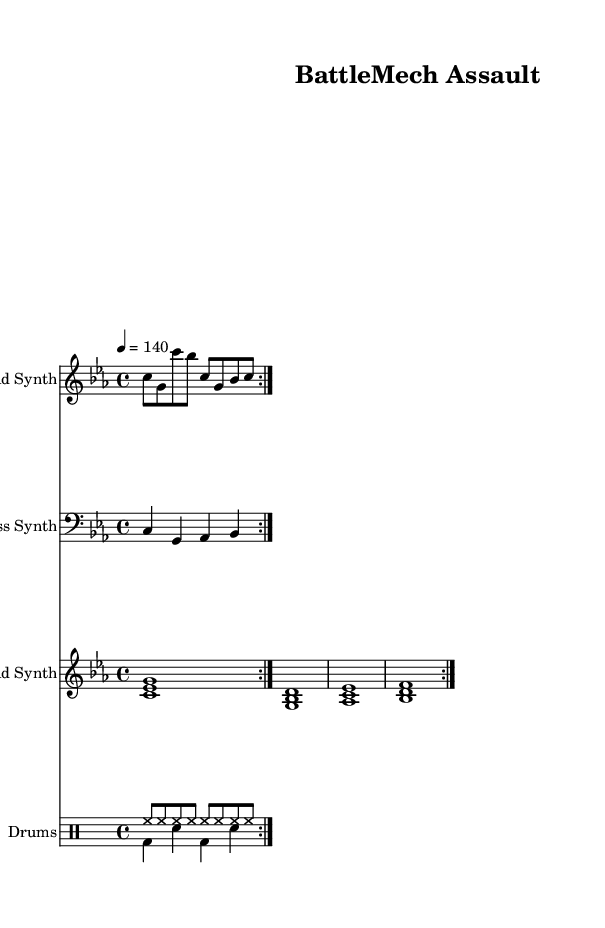What is the key signature of this music? The key signature indicates C minor, which has three flats (B flat, E flat, and A flat). This can be deduced from the global settings in the code that specify the key signature as "c \minor."
Answer: C minor What is the time signature of this music? The time signature is indicated by the "\time" command in the global section of the code, which shows that it is set to 4/4. This means there are four beats per measure and the quarter note gets one beat.
Answer: 4/4 What is the tempo marking? The tempo is specified in the global settings as "4 = 140," meaning that the quarter note is played at a speed of 140 beats per minute. The indication of tempo can be found in the code under the global settings, where it details the beats per minute.
Answer: 140 How many measures are repeated in the lead synth section? The lead synth part has a "repeat volta" command that indicates a section is repeated twice. Therefore, this segment of the sheet music repeats for two measures. This can be found in the part defining the lead synth.
Answer: 2 What instrument plays the bass synth? The bass synth is defined in the music sheet under the section that states "\new Staff \with { instrumentName = 'Bass Synth' }." This directly indicates that the instrument responsible for this part is the bass synth.
Answer: Bass Synth What is the rhythmic pattern in the drum section? The drum section consists of a drum pattern that includes hi-hat (hh) hits represented in eighth notes and bass (bd) and snare (sn) hits in quarter notes, repeated in the drum voices. This specific rhythmic pattern is identified in the drum patterns defined in the code.
Answer: Hi-hat and bass-snare pattern What type of music is this score intended for? The title "BattleMech Assault" suggests that this score is tailored for a futuristic techno music style, inspired by sci-fi themes and integrating space-age synths. The overall structure and synth instrumentation align with the characteristics of dance music.
Answer: Futuristic techno 